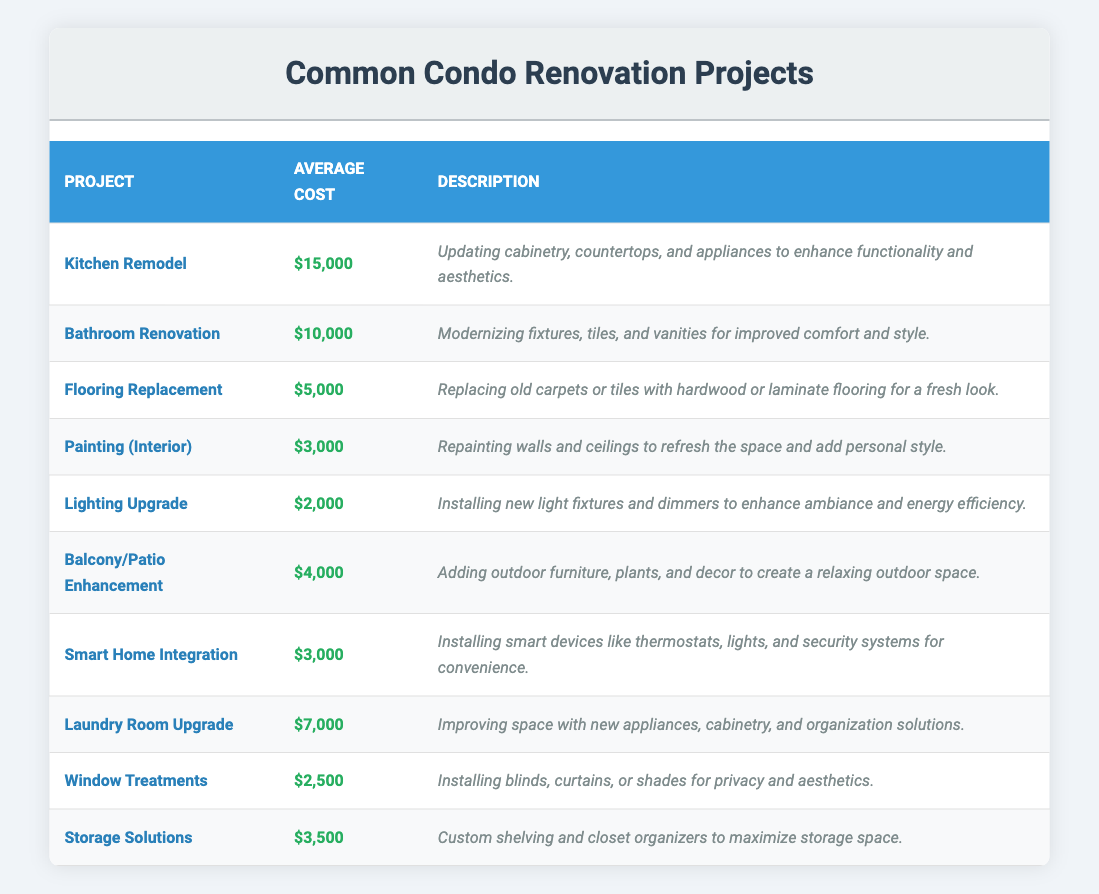What is the average cost of a Kitchen Remodel? The table shows the average cost for each renovation project. For the Kitchen Remodel, the average cost is listed as $15,000.
Answer: $15,000 How much does it cost on average to paint the interior of a condo? The average cost of Painting (Interior) is specified in the table, which states it is $3,000.
Answer: $3,000 What is the total cost of a Bathroom Renovation and a Flooring Replacement? According to the table, the Bathroom Renovation costs $10,000, and Flooring Replacement costs $5,000. Therefore, the total cost is $10,000 + $5,000 = $15,000.
Answer: $15,000 Is the average cost of a Smart Home Integration less than $4,000? The average cost of Smart Home Integration is $3,000 according to the table, which is less than $4,000. Therefore, the statement is true.
Answer: Yes What is the difference in average costs between a Kitchen Remodel and a Lighting Upgrade? The average cost for a Kitchen Remodel is $15,000 and for a Lighting Upgrade, it is $2,000. The difference is $15,000 - $2,000 = $13,000.
Answer: $13,000 Which renovation project has the lowest average cost? Reviewing the average costs in the table, the Lighting Upgrade has the lowest cost at $2,000.
Answer: Lighting Upgrade What is the average cost of all the mentioned renovation projects? To find the average, sum up all the average costs: $15,000 (Kitchen) + $10,000 (Bathroom) + $5,000 (Flooring) + $3,000 (Painting) + $2,000 (Lighting) + $4,000 (Balcony) + $3,000 (Smart Home) + $7,000 (Laundry) + $2,500 (Window Treatments) + $3,500 (Storage) = $54,000. There are 10 projects, so the average cost is $54,000 / 10 = $5,400.
Answer: $5,400 Are there more renovation projects with an average cost of over $5,000 or under $5,000? Counting from the table, there are 5 projects over $5,000 (Kitchen, Bathroom, Laundry, Flooring, and Balcony) and 5 under $5,000 (Painting, Lighting, Smart Home, Window Treatments, and Storage). Thus, they are equal.
Answer: Equal What renovations involve enhancing functionality or aesthetics? The Kitchen Remodel and Bathroom Renovation projects focus on enhancing functionality and aesthetics, as described in their respective entries.
Answer: Kitchen Remodel and Bathroom Renovation Which renovation costs $7,000? According to the table, the Laundry Room Upgrade has an average cost of $7,000.
Answer: Laundry Room Upgrade Which project has a cost larger than $12,000? The table indicates that only the Kitchen Remodel at $15,000 is greater than $12,000.
Answer: Kitchen Remodel 